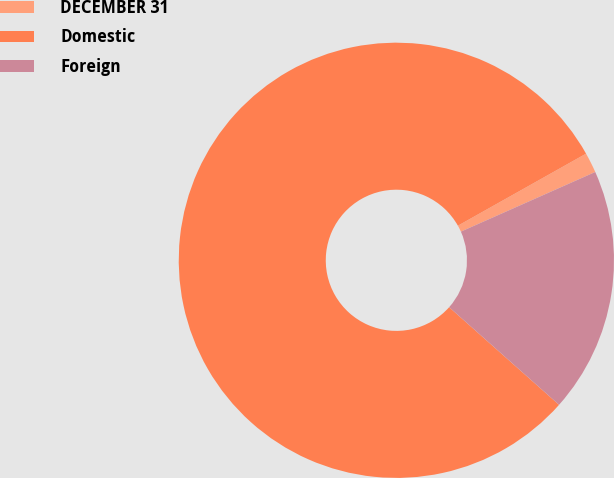Convert chart to OTSL. <chart><loc_0><loc_0><loc_500><loc_500><pie_chart><fcel>DECEMBER 31<fcel>Domestic<fcel>Foreign<nl><fcel>1.5%<fcel>80.29%<fcel>18.21%<nl></chart> 